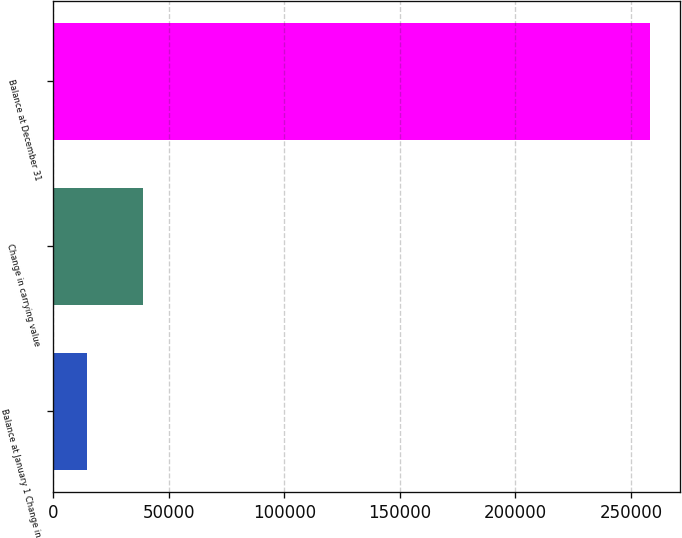Convert chart. <chart><loc_0><loc_0><loc_500><loc_500><bar_chart><fcel>Balance at January 1 Change in<fcel>Change in carrying value<fcel>Balance at December 31<nl><fcel>14544<fcel>38917.6<fcel>258280<nl></chart> 